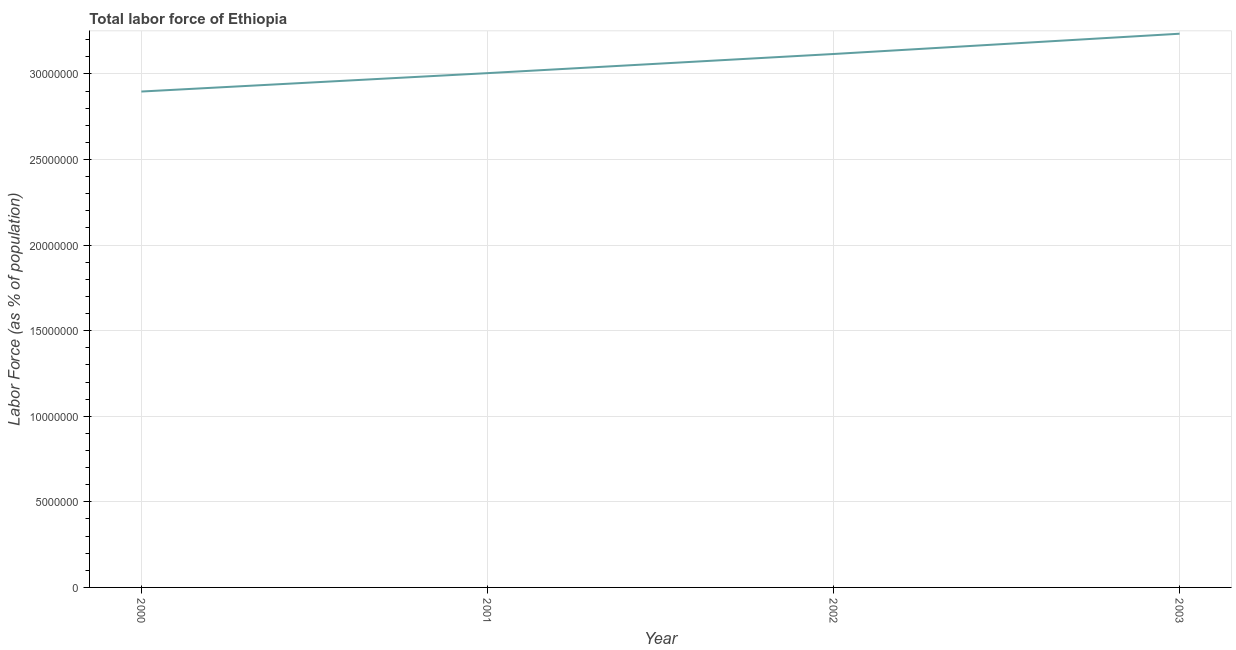What is the total labor force in 2003?
Keep it short and to the point. 3.24e+07. Across all years, what is the maximum total labor force?
Your answer should be compact. 3.24e+07. Across all years, what is the minimum total labor force?
Your answer should be very brief. 2.90e+07. In which year was the total labor force maximum?
Provide a short and direct response. 2003. What is the sum of the total labor force?
Provide a short and direct response. 1.23e+08. What is the difference between the total labor force in 2000 and 2003?
Offer a terse response. -3.38e+06. What is the average total labor force per year?
Offer a terse response. 3.06e+07. What is the median total labor force?
Your answer should be compact. 3.06e+07. Do a majority of the years between 2003 and 2002 (inclusive) have total labor force greater than 30000000 %?
Keep it short and to the point. No. What is the ratio of the total labor force in 2001 to that in 2003?
Your answer should be very brief. 0.93. Is the difference between the total labor force in 2000 and 2002 greater than the difference between any two years?
Make the answer very short. No. What is the difference between the highest and the second highest total labor force?
Provide a short and direct response. 1.19e+06. What is the difference between the highest and the lowest total labor force?
Give a very brief answer. 3.38e+06. Does the total labor force monotonically increase over the years?
Offer a very short reply. Yes. What is the difference between two consecutive major ticks on the Y-axis?
Keep it short and to the point. 5.00e+06. Are the values on the major ticks of Y-axis written in scientific E-notation?
Give a very brief answer. No. Does the graph contain any zero values?
Your answer should be very brief. No. Does the graph contain grids?
Provide a short and direct response. Yes. What is the title of the graph?
Your response must be concise. Total labor force of Ethiopia. What is the label or title of the X-axis?
Provide a succinct answer. Year. What is the label or title of the Y-axis?
Provide a succinct answer. Labor Force (as % of population). What is the Labor Force (as % of population) in 2000?
Your answer should be very brief. 2.90e+07. What is the Labor Force (as % of population) in 2001?
Your response must be concise. 3.00e+07. What is the Labor Force (as % of population) in 2002?
Offer a terse response. 3.12e+07. What is the Labor Force (as % of population) of 2003?
Provide a short and direct response. 3.24e+07. What is the difference between the Labor Force (as % of population) in 2000 and 2001?
Provide a succinct answer. -1.07e+06. What is the difference between the Labor Force (as % of population) in 2000 and 2002?
Your answer should be very brief. -2.19e+06. What is the difference between the Labor Force (as % of population) in 2000 and 2003?
Provide a succinct answer. -3.38e+06. What is the difference between the Labor Force (as % of population) in 2001 and 2002?
Give a very brief answer. -1.12e+06. What is the difference between the Labor Force (as % of population) in 2001 and 2003?
Offer a very short reply. -2.30e+06. What is the difference between the Labor Force (as % of population) in 2002 and 2003?
Your response must be concise. -1.19e+06. What is the ratio of the Labor Force (as % of population) in 2000 to that in 2001?
Offer a terse response. 0.96. What is the ratio of the Labor Force (as % of population) in 2000 to that in 2002?
Your answer should be compact. 0.93. What is the ratio of the Labor Force (as % of population) in 2000 to that in 2003?
Your answer should be compact. 0.9. What is the ratio of the Labor Force (as % of population) in 2001 to that in 2003?
Your response must be concise. 0.93. 